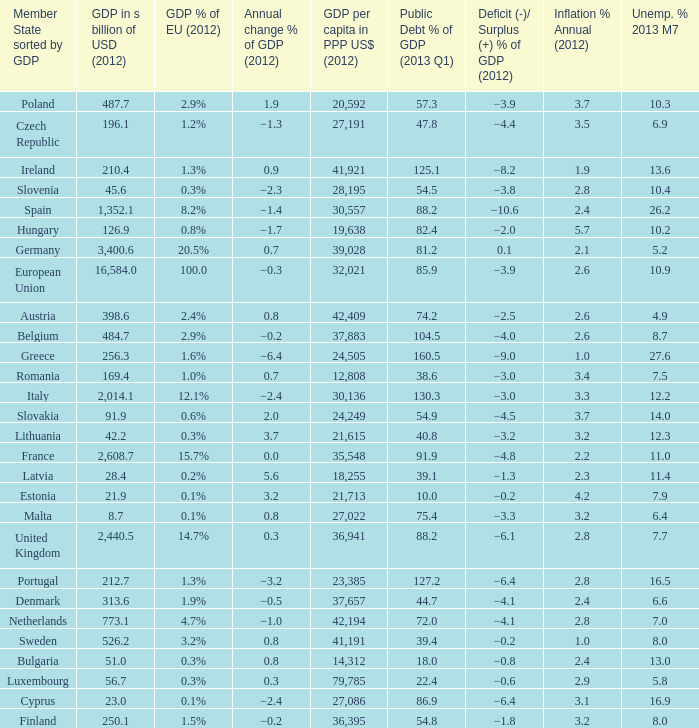What is the deficit/surplus % of the 2012 GDP of the country with a GDP in billions of USD in 2012 less than 1,352.1, a GDP per capita in PPP US dollars in 2012 greater than 21,615, public debt % of GDP in the 2013 Q1 less than 75.4, and an inflation % annual in 2012 of 2.9? −0.6. 